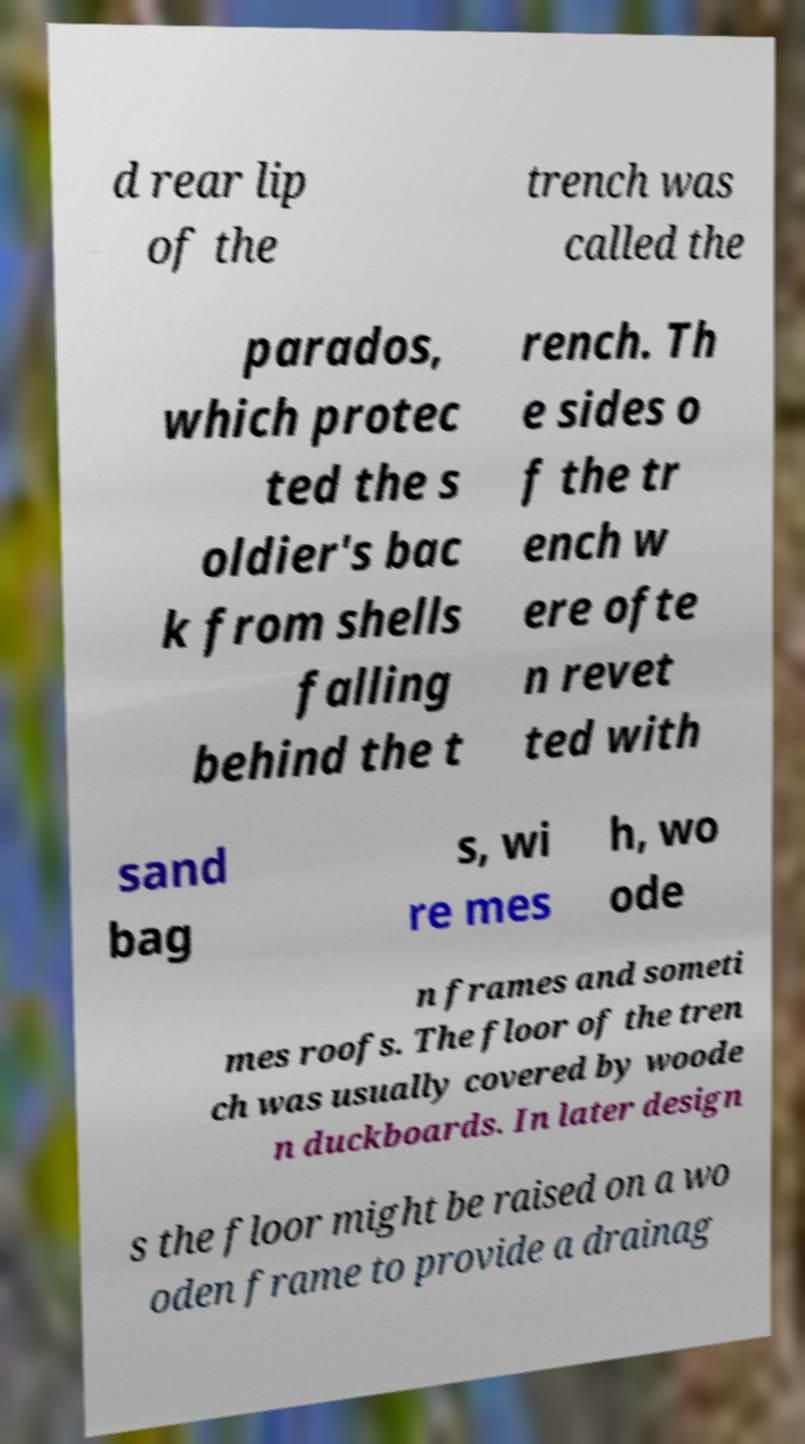For documentation purposes, I need the text within this image transcribed. Could you provide that? d rear lip of the trench was called the parados, which protec ted the s oldier's bac k from shells falling behind the t rench. Th e sides o f the tr ench w ere ofte n revet ted with sand bag s, wi re mes h, wo ode n frames and someti mes roofs. The floor of the tren ch was usually covered by woode n duckboards. In later design s the floor might be raised on a wo oden frame to provide a drainag 